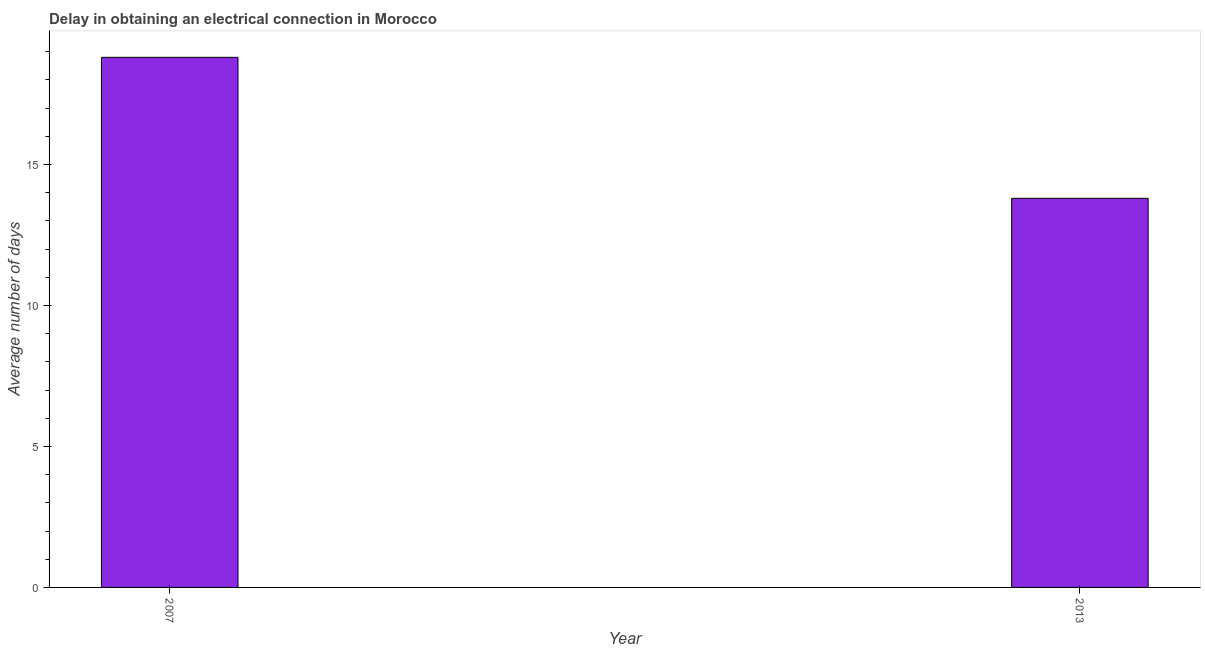What is the title of the graph?
Give a very brief answer. Delay in obtaining an electrical connection in Morocco. What is the label or title of the Y-axis?
Provide a short and direct response. Average number of days. Across all years, what is the maximum dalay in electrical connection?
Make the answer very short. 18.8. In which year was the dalay in electrical connection minimum?
Provide a succinct answer. 2013. What is the sum of the dalay in electrical connection?
Your answer should be very brief. 32.6. What is the median dalay in electrical connection?
Make the answer very short. 16.3. Do a majority of the years between 2007 and 2013 (inclusive) have dalay in electrical connection greater than 16 days?
Provide a short and direct response. No. What is the ratio of the dalay in electrical connection in 2007 to that in 2013?
Provide a succinct answer. 1.36. Is the dalay in electrical connection in 2007 less than that in 2013?
Keep it short and to the point. No. How many bars are there?
Your answer should be compact. 2. How many years are there in the graph?
Give a very brief answer. 2. What is the Average number of days of 2007?
Make the answer very short. 18.8. What is the Average number of days of 2013?
Your response must be concise. 13.8. What is the difference between the Average number of days in 2007 and 2013?
Provide a succinct answer. 5. What is the ratio of the Average number of days in 2007 to that in 2013?
Ensure brevity in your answer.  1.36. 